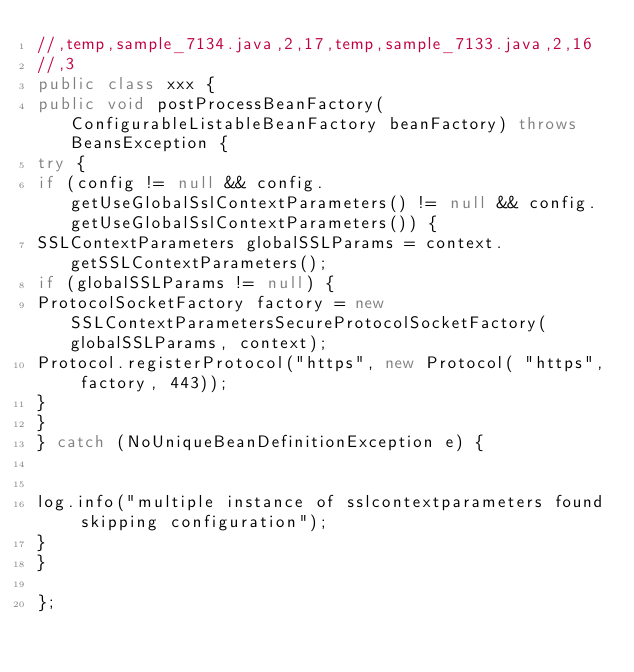Convert code to text. <code><loc_0><loc_0><loc_500><loc_500><_Java_>//,temp,sample_7134.java,2,17,temp,sample_7133.java,2,16
//,3
public class xxx {
public void postProcessBeanFactory(ConfigurableListableBeanFactory beanFactory) throws BeansException {
try {
if (config != null && config.getUseGlobalSslContextParameters() != null && config.getUseGlobalSslContextParameters()) {
SSLContextParameters globalSSLParams = context.getSSLContextParameters();
if (globalSSLParams != null) {
ProtocolSocketFactory factory = new SSLContextParametersSecureProtocolSocketFactory(globalSSLParams, context);
Protocol.registerProtocol("https", new Protocol( "https", factory, 443));
}
}
} catch (NoUniqueBeanDefinitionException e) {


log.info("multiple instance of sslcontextparameters found skipping configuration");
}
}

};</code> 